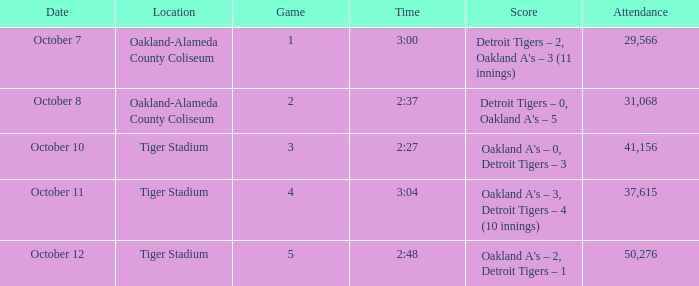What was the score at Tiger Stadium on October 12? Oakland A's – 2, Detroit Tigers – 1. 